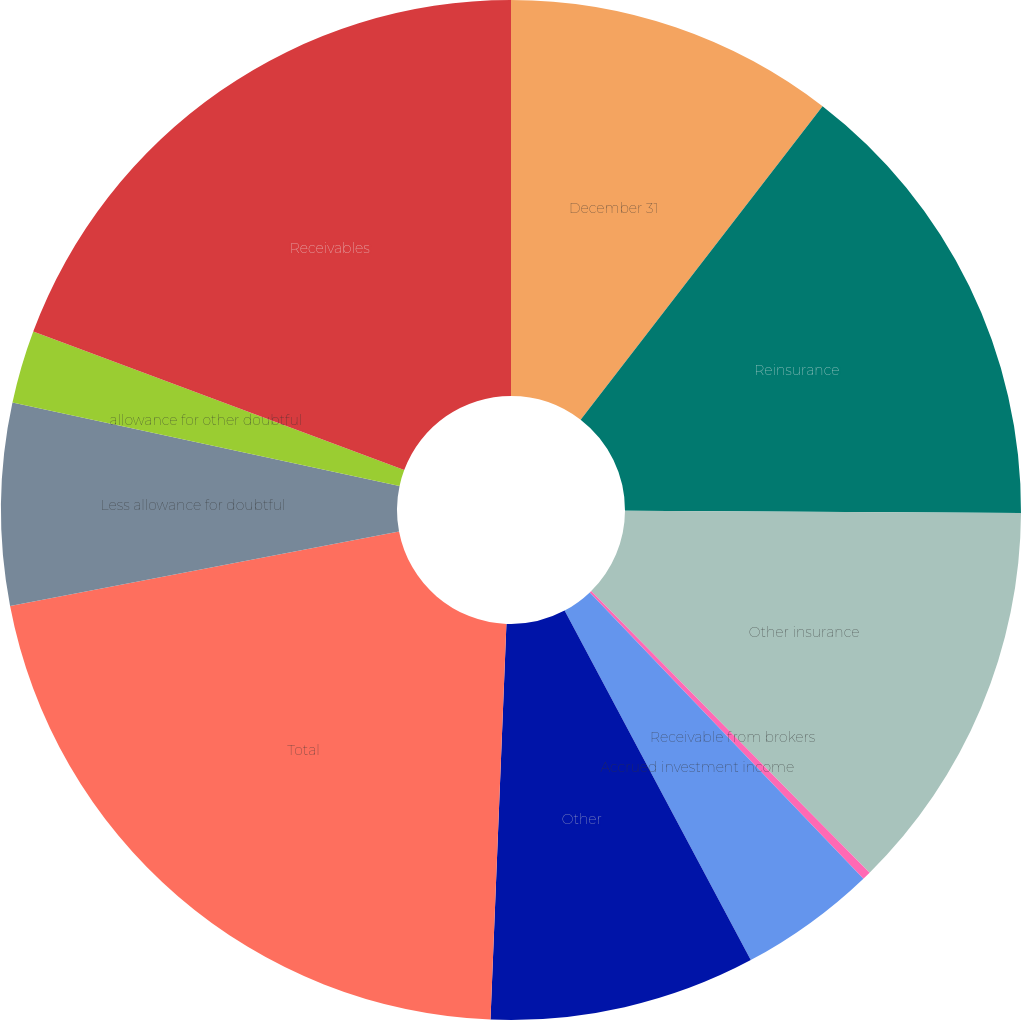<chart> <loc_0><loc_0><loc_500><loc_500><pie_chart><fcel>December 31<fcel>Reinsurance<fcel>Other insurance<fcel>Receivable from brokers<fcel>Accrued investment income<fcel>Other<fcel>Total<fcel>Less allowance for doubtful<fcel>allowance for other doubtful<fcel>Receivables<nl><fcel>10.46%<fcel>14.63%<fcel>12.5%<fcel>0.27%<fcel>4.35%<fcel>8.43%<fcel>21.35%<fcel>6.39%<fcel>2.31%<fcel>19.31%<nl></chart> 